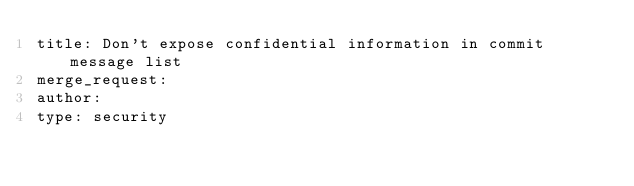<code> <loc_0><loc_0><loc_500><loc_500><_YAML_>title: Don't expose confidential information in commit message list
merge_request:
author:
type: security
</code> 